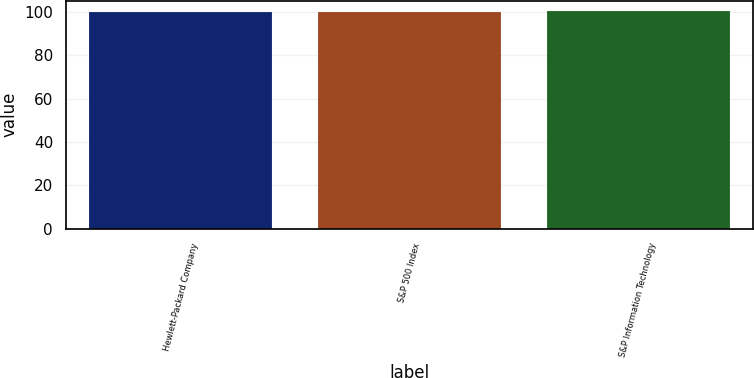Convert chart. <chart><loc_0><loc_0><loc_500><loc_500><bar_chart><fcel>Hewlett-Packard Company<fcel>S&P 500 Index<fcel>S&P Information Technology<nl><fcel>100<fcel>100.1<fcel>100.2<nl></chart> 